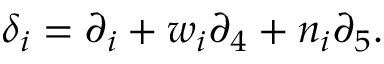<formula> <loc_0><loc_0><loc_500><loc_500>\delta _ { i } = \partial _ { i } + w _ { i } \partial _ { 4 } + n _ { i } \partial _ { 5 } .</formula> 